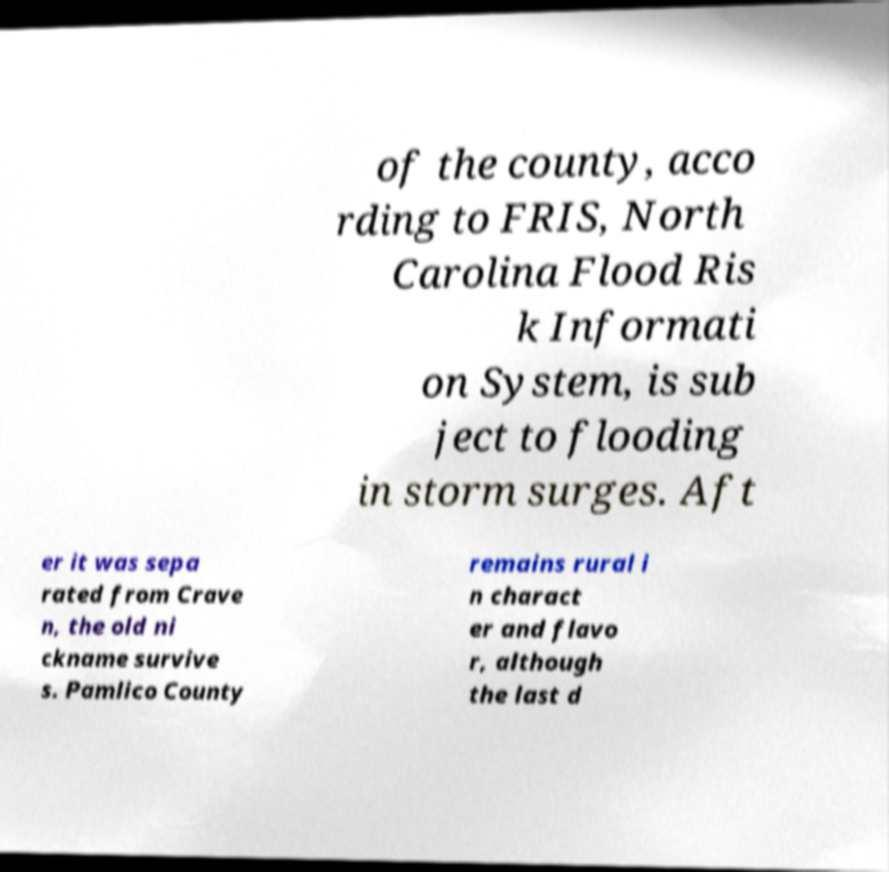What messages or text are displayed in this image? I need them in a readable, typed format. of the county, acco rding to FRIS, North Carolina Flood Ris k Informati on System, is sub ject to flooding in storm surges. Aft er it was sepa rated from Crave n, the old ni ckname survive s. Pamlico County remains rural i n charact er and flavo r, although the last d 